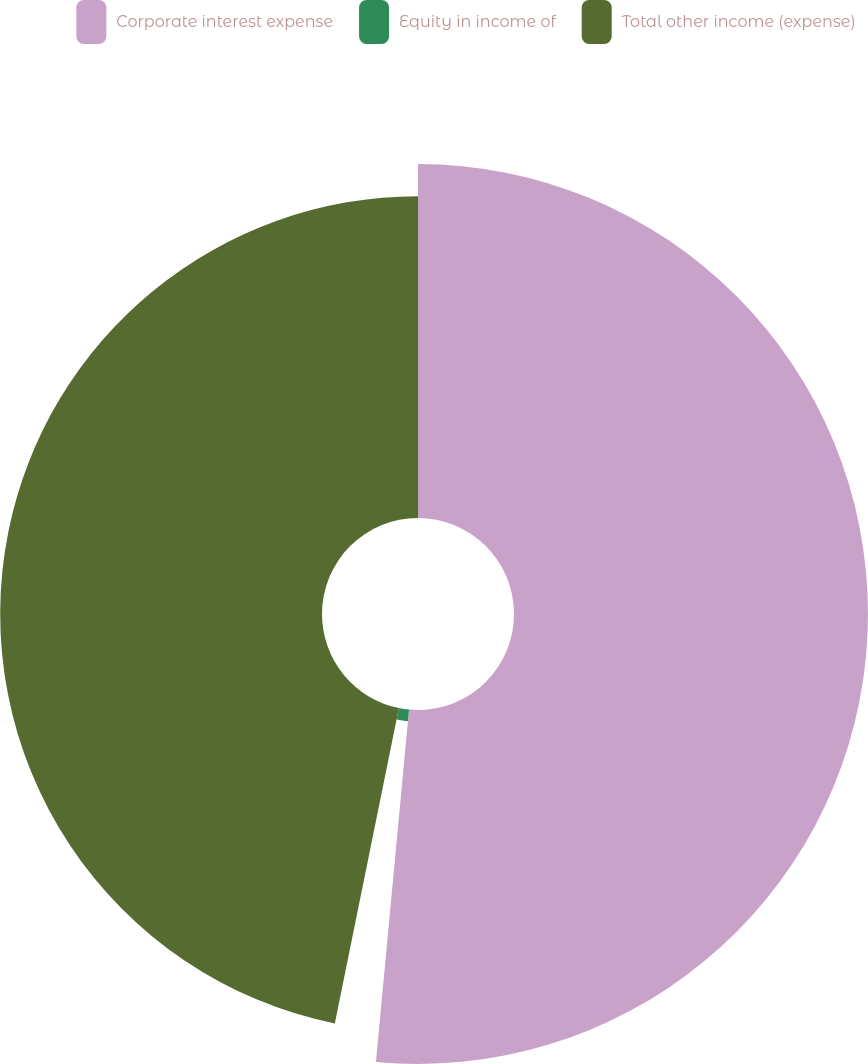Convert chart to OTSL. <chart><loc_0><loc_0><loc_500><loc_500><pie_chart><fcel>Corporate interest expense<fcel>Equity in income of<fcel>Total other income (expense)<nl><fcel>51.49%<fcel>1.7%<fcel>46.81%<nl></chart> 